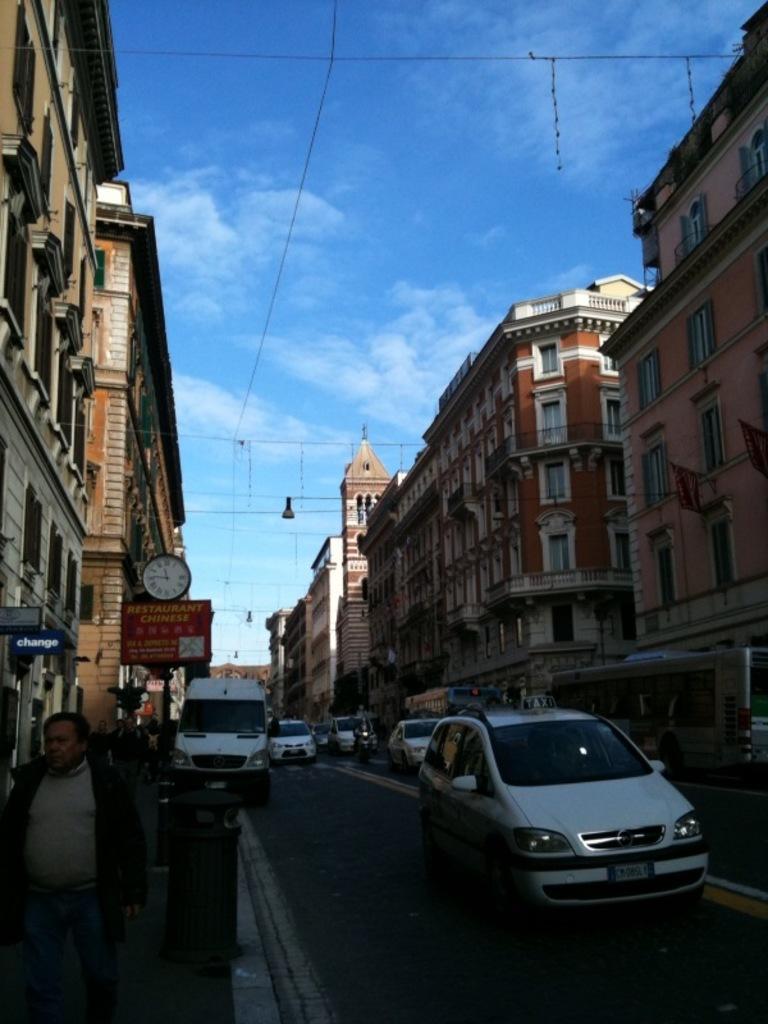Could you give a brief overview of what you see in this image? In the bottom left corner of the image few persons are walking. In the middle of the image we can see some vehicles on the road. Behind the vehicles we can see some buildings. At the top of the image we can see some clouds in the sky. 